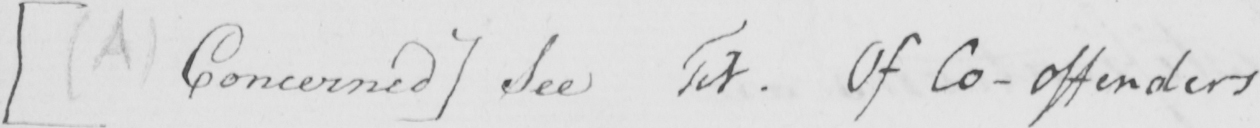Please transcribe the handwritten text in this image. [  ( A )  Concerned ]  See Tit . Of Co-offenders . 